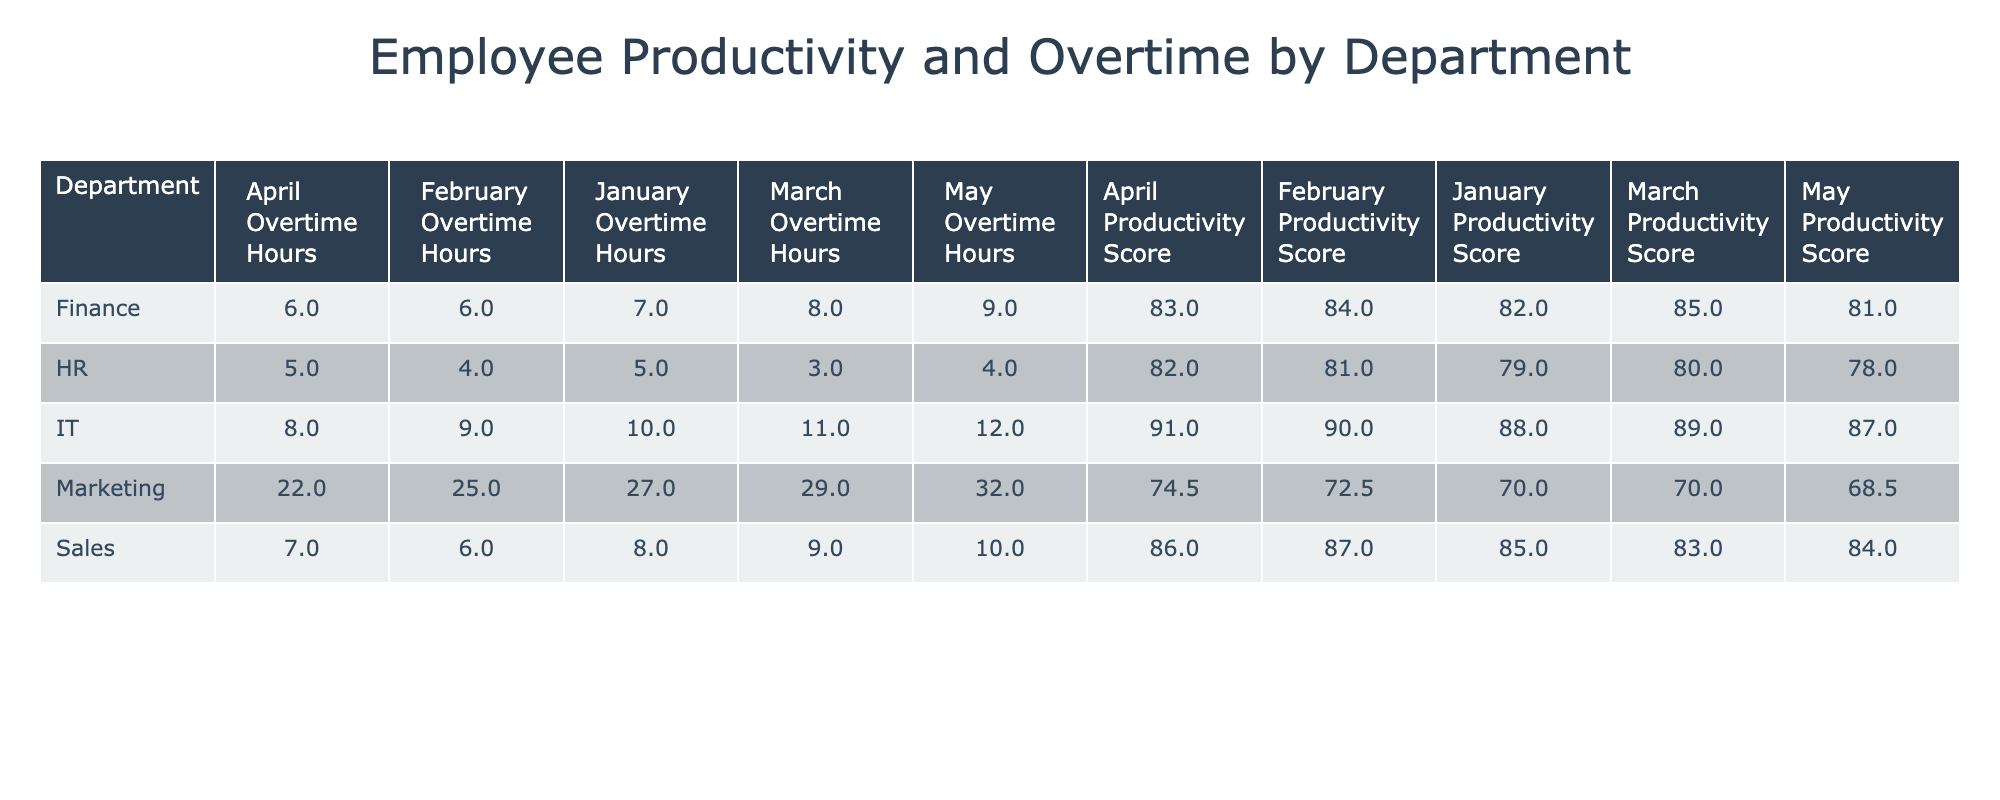What is the average productivity score for the Marketing department in February? To find the average productivity score for the Marketing department in February, we look at the productivity scores specifically for that month. The scores are 70 and 75 for the two Marketing employees in February. The average is calculated as (70 + 75) / 2 = 145 / 2 = 72.5.
Answer: 72.5 Which department had the highest total overtime hours in March? In March, we need to sum the overtime hours for each department. The overtime hours for March are: Marketing (16 + 13 + 18 = 47), Sales (9), HR (3), IT (11), Finance (8). The totals are Marketing 47, Sales 9, HR 3, IT 11, Finance 8. The highest total is for the Marketing department with 47 hours.
Answer: Marketing Did the Finance department ever have a productivity score above 85? Checking the productivity scores for the Finance department in all months: January (82), February (84), March (85), and May (81). None of these scores exceed 85, so the answer is no.
Answer: No What is the difference in average productivity score between the Sales and HR departments for January? The productivity scores for Sales in January is 85, and for HR, it is 79. To find the difference: 85 (Sales) - 79 (HR) = 6. Thus, the difference in average productivity is 6 points.
Answer: 6 Which month did the IT department have the highest average productivity score? The IT department has the following productivity scores: January (88), February (90), March (89), and April (91). The highest average score is in April at 91.
Answer: April What were the total overtime hours for all departments in January? We add up the overtime hours for each department in January: Marketing (12 + 15), Sales (8), HR (5), IT (10), and Finance (7). Thus, total overtime = (12 + 15 + 8 + 5 + 10 + 7) = 57 hours.
Answer: 57 How many employees in the Marketing department had a productivity score below 70 in January? In January, the Marketing employees were John Smith (72), Sarah Johnson (68), and Chris Evans (70). Only Sarah Johnson had a score below 70.
Answer: 1 What was the marked increase in overtime hours for the Marketing department from February to April? The overtime hours for Marketing are: February (11), March (16), and April (10). The increase from February (11) to March (16) is 5 hours. The change from March (16) to April (10) is a decrease of 6 hours, so the total increase from February to April isn't applicable, indicating fluctuation.
Answer: No increase 